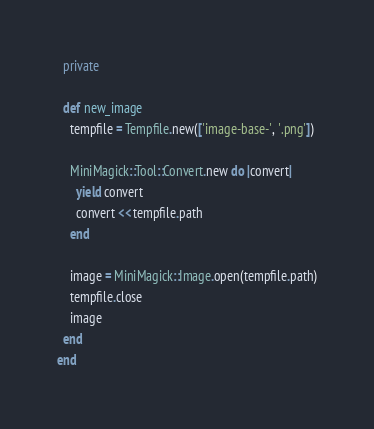Convert code to text. <code><loc_0><loc_0><loc_500><loc_500><_Ruby_>  private

  def new_image
    tempfile = Tempfile.new(['image-base-', '.png'])

    MiniMagick::Tool::Convert.new do |convert|
      yield convert
      convert << tempfile.path
    end

    image = MiniMagick::Image.open(tempfile.path)
    tempfile.close
    image
  end
end
</code> 